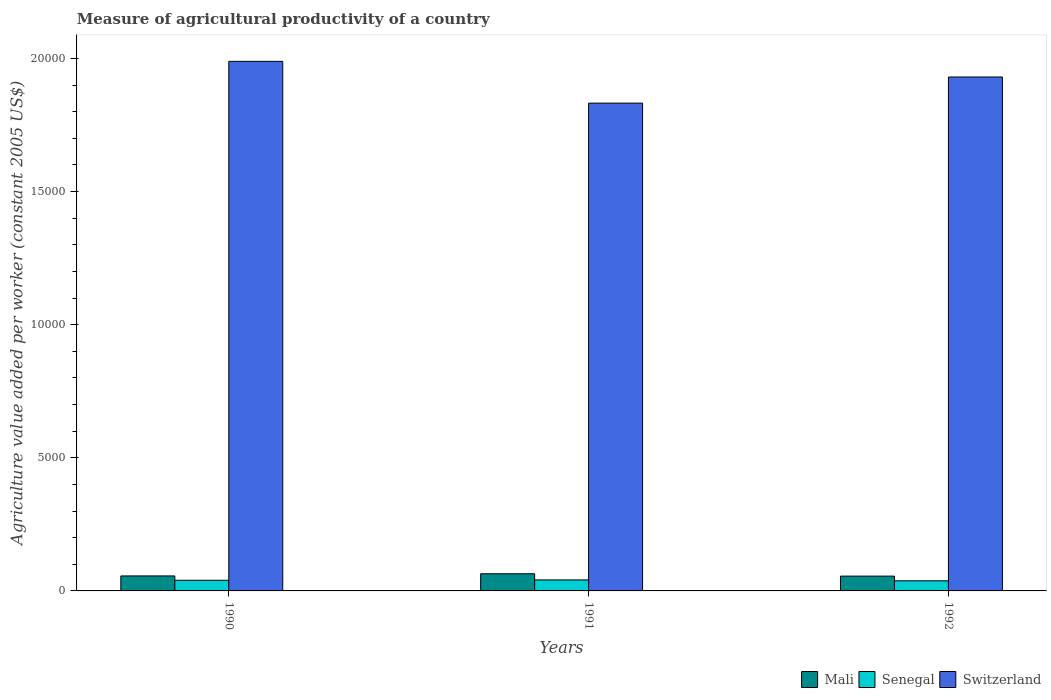How many groups of bars are there?
Offer a very short reply. 3. Are the number of bars per tick equal to the number of legend labels?
Your answer should be compact. Yes. How many bars are there on the 3rd tick from the left?
Offer a very short reply. 3. What is the label of the 2nd group of bars from the left?
Provide a succinct answer. 1991. In how many cases, is the number of bars for a given year not equal to the number of legend labels?
Your response must be concise. 0. What is the measure of agricultural productivity in Switzerland in 1990?
Provide a succinct answer. 1.99e+04. Across all years, what is the maximum measure of agricultural productivity in Switzerland?
Give a very brief answer. 1.99e+04. Across all years, what is the minimum measure of agricultural productivity in Senegal?
Provide a short and direct response. 379.18. In which year was the measure of agricultural productivity in Switzerland maximum?
Offer a terse response. 1990. What is the total measure of agricultural productivity in Switzerland in the graph?
Give a very brief answer. 5.75e+04. What is the difference between the measure of agricultural productivity in Mali in 1991 and that in 1992?
Your response must be concise. 88.42. What is the difference between the measure of agricultural productivity in Switzerland in 1992 and the measure of agricultural productivity in Senegal in 1991?
Make the answer very short. 1.89e+04. What is the average measure of agricultural productivity in Mali per year?
Offer a terse response. 587.87. In the year 1991, what is the difference between the measure of agricultural productivity in Senegal and measure of agricultural productivity in Switzerland?
Give a very brief answer. -1.79e+04. What is the ratio of the measure of agricultural productivity in Mali in 1990 to that in 1991?
Make the answer very short. 0.87. Is the difference between the measure of agricultural productivity in Senegal in 1990 and 1991 greater than the difference between the measure of agricultural productivity in Switzerland in 1990 and 1991?
Your answer should be compact. No. What is the difference between the highest and the second highest measure of agricultural productivity in Senegal?
Your response must be concise. 13.79. What is the difference between the highest and the lowest measure of agricultural productivity in Switzerland?
Your response must be concise. 1568.43. In how many years, is the measure of agricultural productivity in Mali greater than the average measure of agricultural productivity in Mali taken over all years?
Your response must be concise. 1. Is the sum of the measure of agricultural productivity in Switzerland in 1990 and 1991 greater than the maximum measure of agricultural productivity in Mali across all years?
Give a very brief answer. Yes. What does the 3rd bar from the left in 1991 represents?
Keep it short and to the point. Switzerland. What does the 1st bar from the right in 1990 represents?
Offer a terse response. Switzerland. Is it the case that in every year, the sum of the measure of agricultural productivity in Switzerland and measure of agricultural productivity in Mali is greater than the measure of agricultural productivity in Senegal?
Give a very brief answer. Yes. How many bars are there?
Provide a short and direct response. 9. What is the difference between two consecutive major ticks on the Y-axis?
Your answer should be very brief. 5000. Are the values on the major ticks of Y-axis written in scientific E-notation?
Provide a succinct answer. No. Where does the legend appear in the graph?
Your answer should be compact. Bottom right. How many legend labels are there?
Your answer should be compact. 3. How are the legend labels stacked?
Provide a short and direct response. Horizontal. What is the title of the graph?
Make the answer very short. Measure of agricultural productivity of a country. Does "Sub-Saharan Africa (all income levels)" appear as one of the legend labels in the graph?
Your answer should be compact. No. What is the label or title of the X-axis?
Give a very brief answer. Years. What is the label or title of the Y-axis?
Offer a terse response. Agriculture value added per worker (constant 2005 US$). What is the Agriculture value added per worker (constant 2005 US$) of Mali in 1990?
Offer a terse response. 562.8. What is the Agriculture value added per worker (constant 2005 US$) of Senegal in 1990?
Ensure brevity in your answer.  399.78. What is the Agriculture value added per worker (constant 2005 US$) of Switzerland in 1990?
Offer a terse response. 1.99e+04. What is the Agriculture value added per worker (constant 2005 US$) of Mali in 1991?
Your answer should be very brief. 644.61. What is the Agriculture value added per worker (constant 2005 US$) in Senegal in 1991?
Ensure brevity in your answer.  413.57. What is the Agriculture value added per worker (constant 2005 US$) of Switzerland in 1991?
Give a very brief answer. 1.83e+04. What is the Agriculture value added per worker (constant 2005 US$) of Mali in 1992?
Make the answer very short. 556.19. What is the Agriculture value added per worker (constant 2005 US$) in Senegal in 1992?
Your response must be concise. 379.18. What is the Agriculture value added per worker (constant 2005 US$) in Switzerland in 1992?
Your response must be concise. 1.93e+04. Across all years, what is the maximum Agriculture value added per worker (constant 2005 US$) of Mali?
Offer a very short reply. 644.61. Across all years, what is the maximum Agriculture value added per worker (constant 2005 US$) in Senegal?
Ensure brevity in your answer.  413.57. Across all years, what is the maximum Agriculture value added per worker (constant 2005 US$) of Switzerland?
Offer a very short reply. 1.99e+04. Across all years, what is the minimum Agriculture value added per worker (constant 2005 US$) of Mali?
Provide a short and direct response. 556.19. Across all years, what is the minimum Agriculture value added per worker (constant 2005 US$) in Senegal?
Make the answer very short. 379.18. Across all years, what is the minimum Agriculture value added per worker (constant 2005 US$) in Switzerland?
Your answer should be compact. 1.83e+04. What is the total Agriculture value added per worker (constant 2005 US$) of Mali in the graph?
Ensure brevity in your answer.  1763.6. What is the total Agriculture value added per worker (constant 2005 US$) of Senegal in the graph?
Provide a succinct answer. 1192.53. What is the total Agriculture value added per worker (constant 2005 US$) of Switzerland in the graph?
Make the answer very short. 5.75e+04. What is the difference between the Agriculture value added per worker (constant 2005 US$) in Mali in 1990 and that in 1991?
Offer a terse response. -81.81. What is the difference between the Agriculture value added per worker (constant 2005 US$) of Senegal in 1990 and that in 1991?
Ensure brevity in your answer.  -13.79. What is the difference between the Agriculture value added per worker (constant 2005 US$) in Switzerland in 1990 and that in 1991?
Your answer should be very brief. 1568.43. What is the difference between the Agriculture value added per worker (constant 2005 US$) of Mali in 1990 and that in 1992?
Offer a very short reply. 6.61. What is the difference between the Agriculture value added per worker (constant 2005 US$) of Senegal in 1990 and that in 1992?
Keep it short and to the point. 20.6. What is the difference between the Agriculture value added per worker (constant 2005 US$) in Switzerland in 1990 and that in 1992?
Offer a very short reply. 587.34. What is the difference between the Agriculture value added per worker (constant 2005 US$) in Mali in 1991 and that in 1992?
Provide a short and direct response. 88.42. What is the difference between the Agriculture value added per worker (constant 2005 US$) in Senegal in 1991 and that in 1992?
Your answer should be very brief. 34.39. What is the difference between the Agriculture value added per worker (constant 2005 US$) of Switzerland in 1991 and that in 1992?
Make the answer very short. -981.09. What is the difference between the Agriculture value added per worker (constant 2005 US$) in Mali in 1990 and the Agriculture value added per worker (constant 2005 US$) in Senegal in 1991?
Ensure brevity in your answer.  149.23. What is the difference between the Agriculture value added per worker (constant 2005 US$) in Mali in 1990 and the Agriculture value added per worker (constant 2005 US$) in Switzerland in 1991?
Provide a succinct answer. -1.78e+04. What is the difference between the Agriculture value added per worker (constant 2005 US$) of Senegal in 1990 and the Agriculture value added per worker (constant 2005 US$) of Switzerland in 1991?
Give a very brief answer. -1.79e+04. What is the difference between the Agriculture value added per worker (constant 2005 US$) in Mali in 1990 and the Agriculture value added per worker (constant 2005 US$) in Senegal in 1992?
Offer a very short reply. 183.62. What is the difference between the Agriculture value added per worker (constant 2005 US$) in Mali in 1990 and the Agriculture value added per worker (constant 2005 US$) in Switzerland in 1992?
Your answer should be compact. -1.87e+04. What is the difference between the Agriculture value added per worker (constant 2005 US$) in Senegal in 1990 and the Agriculture value added per worker (constant 2005 US$) in Switzerland in 1992?
Your answer should be compact. -1.89e+04. What is the difference between the Agriculture value added per worker (constant 2005 US$) in Mali in 1991 and the Agriculture value added per worker (constant 2005 US$) in Senegal in 1992?
Make the answer very short. 265.43. What is the difference between the Agriculture value added per worker (constant 2005 US$) in Mali in 1991 and the Agriculture value added per worker (constant 2005 US$) in Switzerland in 1992?
Ensure brevity in your answer.  -1.87e+04. What is the difference between the Agriculture value added per worker (constant 2005 US$) of Senegal in 1991 and the Agriculture value added per worker (constant 2005 US$) of Switzerland in 1992?
Provide a short and direct response. -1.89e+04. What is the average Agriculture value added per worker (constant 2005 US$) in Mali per year?
Your answer should be compact. 587.87. What is the average Agriculture value added per worker (constant 2005 US$) of Senegal per year?
Keep it short and to the point. 397.51. What is the average Agriculture value added per worker (constant 2005 US$) of Switzerland per year?
Provide a short and direct response. 1.92e+04. In the year 1990, what is the difference between the Agriculture value added per worker (constant 2005 US$) of Mali and Agriculture value added per worker (constant 2005 US$) of Senegal?
Your response must be concise. 163.02. In the year 1990, what is the difference between the Agriculture value added per worker (constant 2005 US$) of Mali and Agriculture value added per worker (constant 2005 US$) of Switzerland?
Your answer should be compact. -1.93e+04. In the year 1990, what is the difference between the Agriculture value added per worker (constant 2005 US$) of Senegal and Agriculture value added per worker (constant 2005 US$) of Switzerland?
Keep it short and to the point. -1.95e+04. In the year 1991, what is the difference between the Agriculture value added per worker (constant 2005 US$) of Mali and Agriculture value added per worker (constant 2005 US$) of Senegal?
Provide a short and direct response. 231.04. In the year 1991, what is the difference between the Agriculture value added per worker (constant 2005 US$) of Mali and Agriculture value added per worker (constant 2005 US$) of Switzerland?
Offer a terse response. -1.77e+04. In the year 1991, what is the difference between the Agriculture value added per worker (constant 2005 US$) of Senegal and Agriculture value added per worker (constant 2005 US$) of Switzerland?
Offer a terse response. -1.79e+04. In the year 1992, what is the difference between the Agriculture value added per worker (constant 2005 US$) in Mali and Agriculture value added per worker (constant 2005 US$) in Senegal?
Make the answer very short. 177.01. In the year 1992, what is the difference between the Agriculture value added per worker (constant 2005 US$) in Mali and Agriculture value added per worker (constant 2005 US$) in Switzerland?
Give a very brief answer. -1.87e+04. In the year 1992, what is the difference between the Agriculture value added per worker (constant 2005 US$) in Senegal and Agriculture value added per worker (constant 2005 US$) in Switzerland?
Provide a short and direct response. -1.89e+04. What is the ratio of the Agriculture value added per worker (constant 2005 US$) in Mali in 1990 to that in 1991?
Offer a very short reply. 0.87. What is the ratio of the Agriculture value added per worker (constant 2005 US$) in Senegal in 1990 to that in 1991?
Your response must be concise. 0.97. What is the ratio of the Agriculture value added per worker (constant 2005 US$) in Switzerland in 1990 to that in 1991?
Give a very brief answer. 1.09. What is the ratio of the Agriculture value added per worker (constant 2005 US$) of Mali in 1990 to that in 1992?
Make the answer very short. 1.01. What is the ratio of the Agriculture value added per worker (constant 2005 US$) in Senegal in 1990 to that in 1992?
Provide a short and direct response. 1.05. What is the ratio of the Agriculture value added per worker (constant 2005 US$) of Switzerland in 1990 to that in 1992?
Your response must be concise. 1.03. What is the ratio of the Agriculture value added per worker (constant 2005 US$) of Mali in 1991 to that in 1992?
Provide a succinct answer. 1.16. What is the ratio of the Agriculture value added per worker (constant 2005 US$) of Senegal in 1991 to that in 1992?
Give a very brief answer. 1.09. What is the ratio of the Agriculture value added per worker (constant 2005 US$) of Switzerland in 1991 to that in 1992?
Provide a short and direct response. 0.95. What is the difference between the highest and the second highest Agriculture value added per worker (constant 2005 US$) of Mali?
Your answer should be very brief. 81.81. What is the difference between the highest and the second highest Agriculture value added per worker (constant 2005 US$) of Senegal?
Provide a short and direct response. 13.79. What is the difference between the highest and the second highest Agriculture value added per worker (constant 2005 US$) of Switzerland?
Provide a succinct answer. 587.34. What is the difference between the highest and the lowest Agriculture value added per worker (constant 2005 US$) of Mali?
Provide a succinct answer. 88.42. What is the difference between the highest and the lowest Agriculture value added per worker (constant 2005 US$) of Senegal?
Give a very brief answer. 34.39. What is the difference between the highest and the lowest Agriculture value added per worker (constant 2005 US$) in Switzerland?
Make the answer very short. 1568.43. 